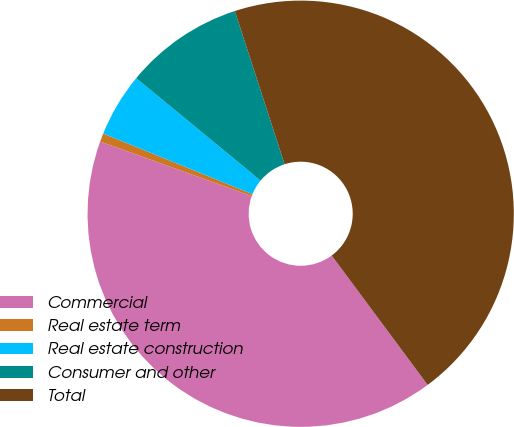Convert chart to OTSL. <chart><loc_0><loc_0><loc_500><loc_500><pie_chart><fcel>Commercial<fcel>Real estate term<fcel>Real estate construction<fcel>Consumer and other<fcel>Total<nl><fcel>40.66%<fcel>0.64%<fcel>4.83%<fcel>9.03%<fcel>44.85%<nl></chart> 